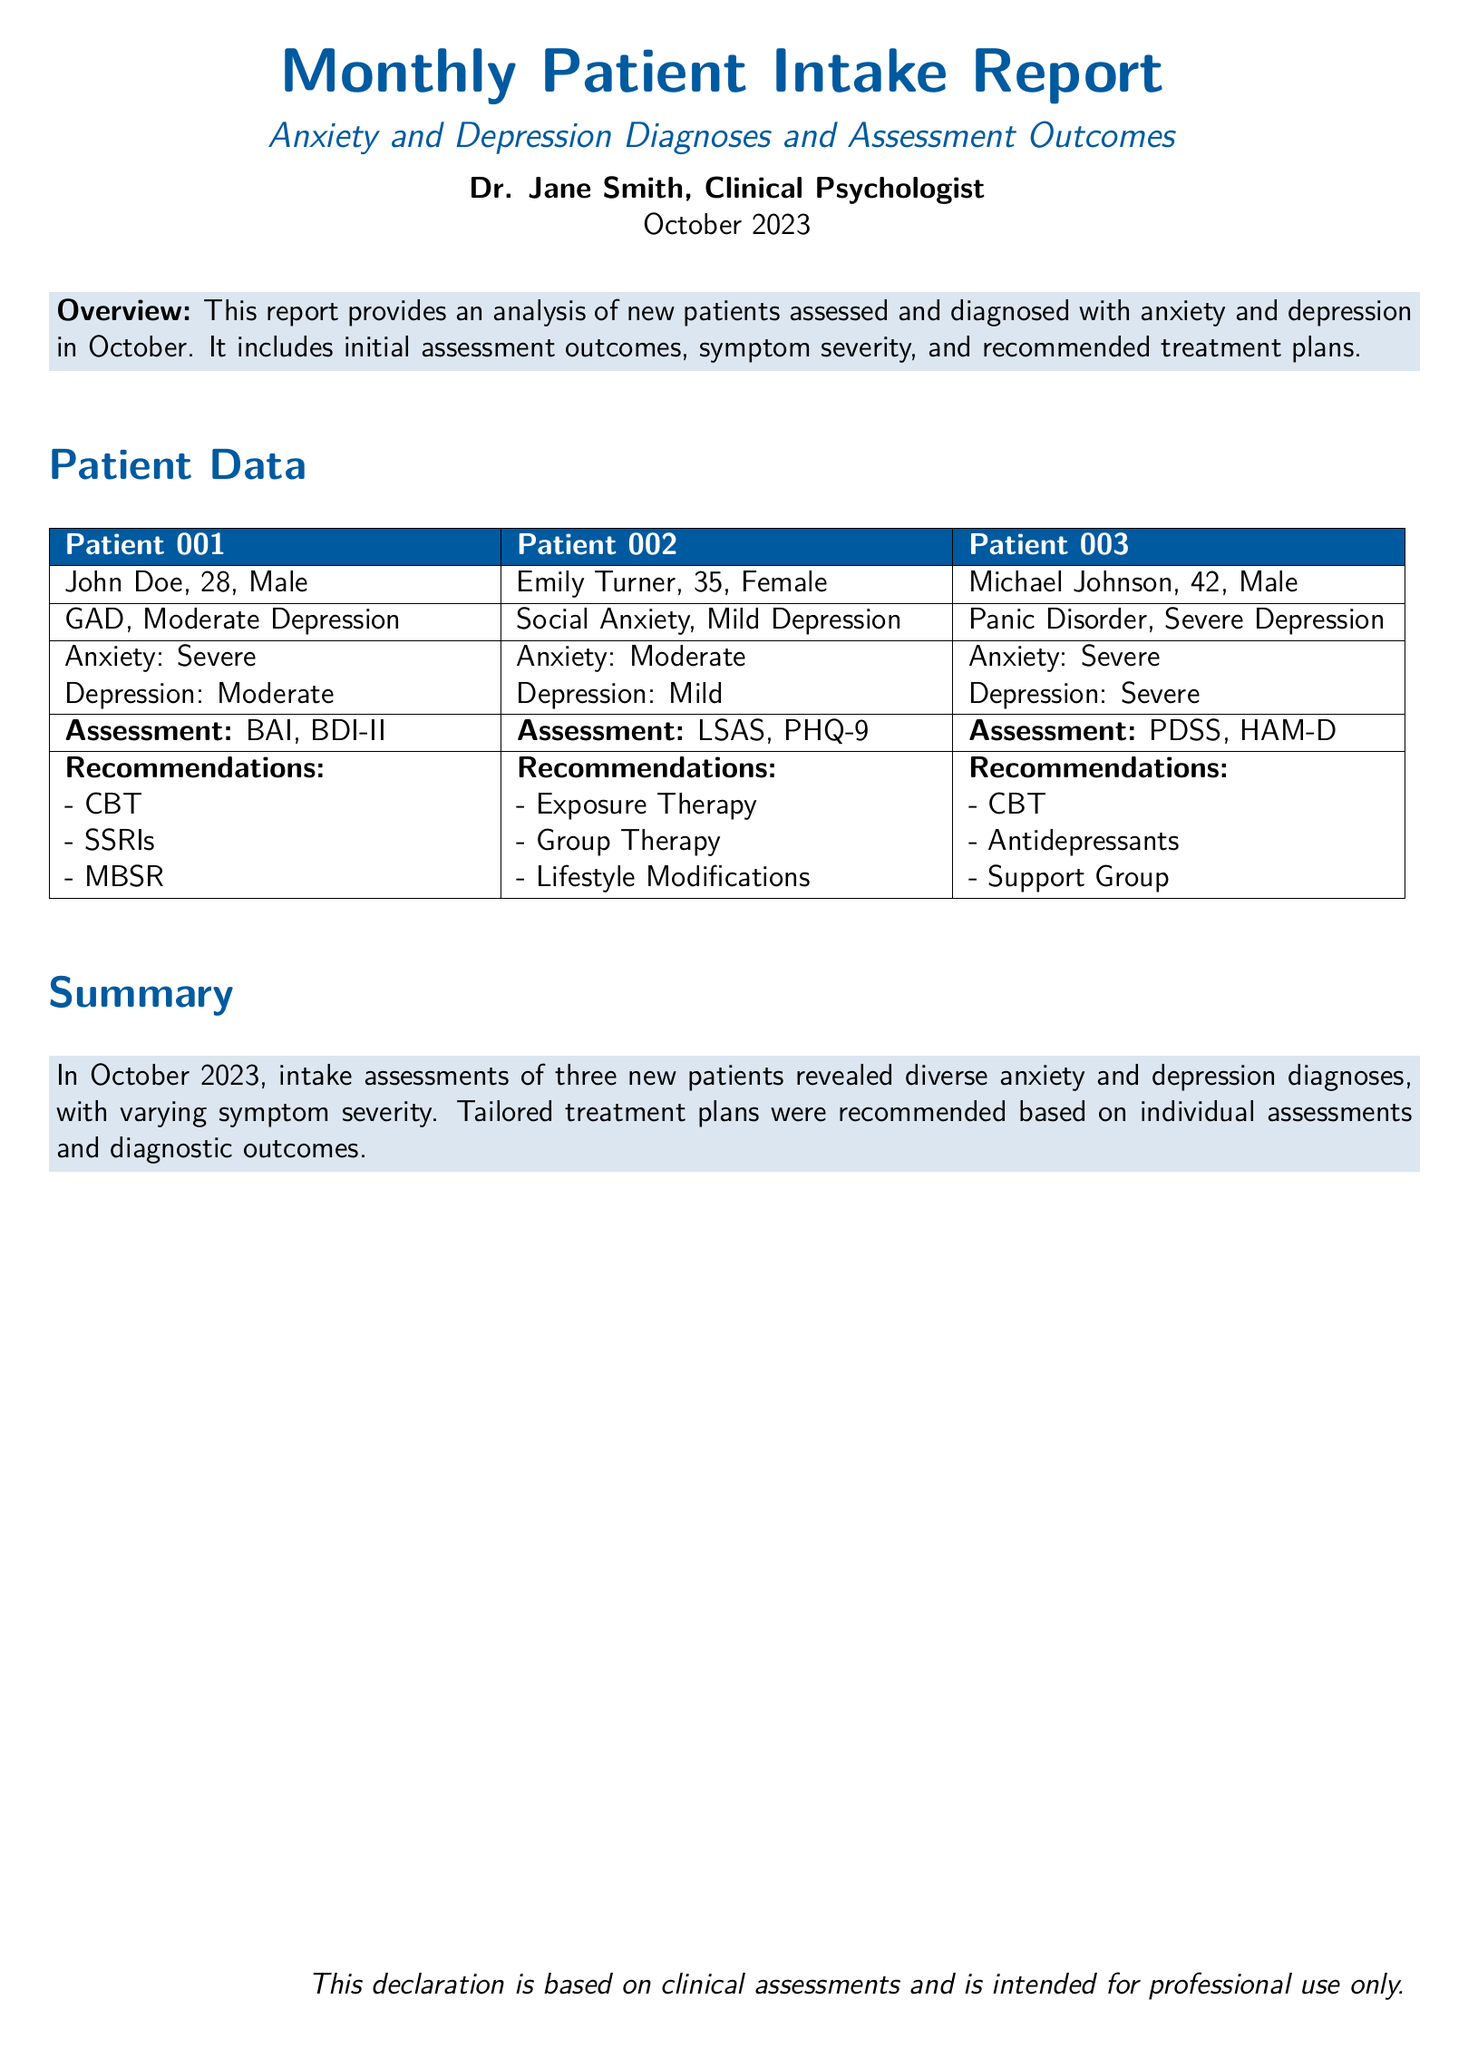What is the name of the psychologist? The name of the psychologist is mentioned at the beginning of the document.
Answer: Dr. Jane Smith How many new patients were assessed in October 2023? The total number of new patients is listed in the summary section of the document.
Answer: Three What is the diagnosis for Patient 001? The diagnosis for Patient 001 is specified in the patient data table.
Answer: GAD, Moderate Depression What severity level of anxiety does Patient 002 have? The severity level of anxiety for Patient 002 is indicated in the patient data table.
Answer: Moderate Which assessment was used for Patient 003? The assessment method for Patient 003 is described in the patient data table.
Answer: PDSS, HAM-D What is the recommended treatment for Patient 001? The recommendations for Patient 001 can be found in the patient data table.
Answer: CBT, SSRIs, MBSR What symptom severity does Michael Johnson have for depression? The severity for depression is listed for Michael Johnson in the patient data table.
Answer: Severe Which treatment plan is not recommended for Patient 002? The recommendation section provides the treatments not mentioned for Patient 002.
Answer: Antidepressants What is the date of the report? The date of the report is included in the introductory section of the document.
Answer: October 2023 